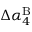Convert formula to latex. <formula><loc_0><loc_0><loc_500><loc_500>\Delta \alpha _ { 4 } ^ { B }</formula> 